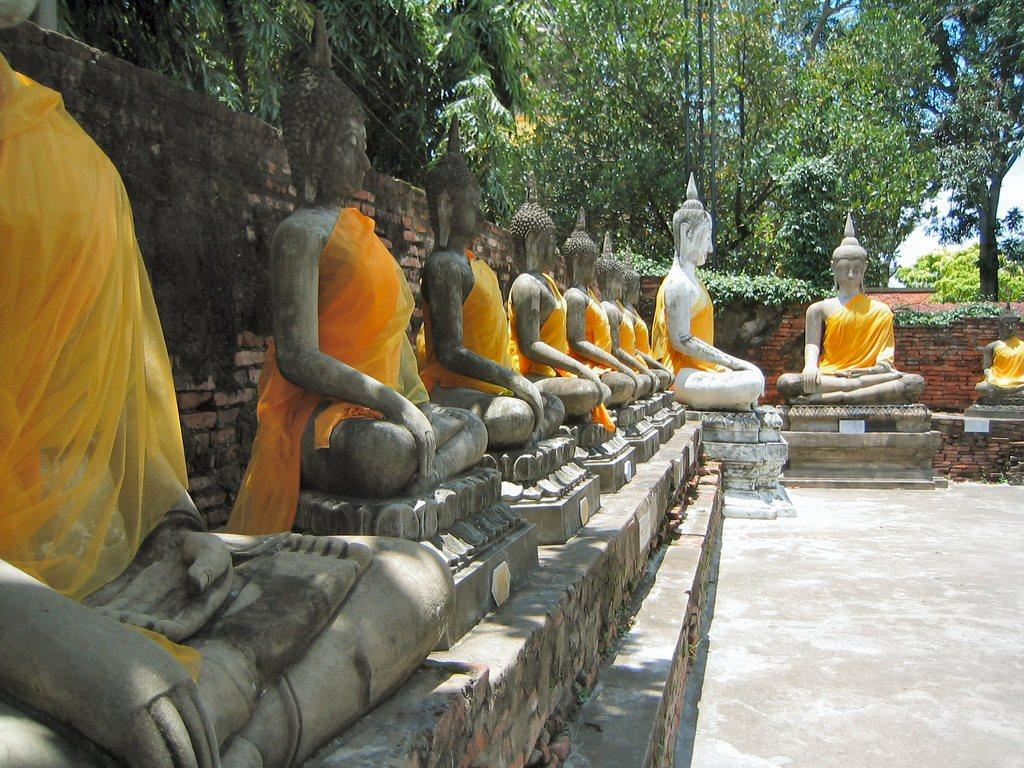What type of statues can be seen in the image? There are buddha statues in the image. What color are the clothes on the statues? The statues have yellow-colored clothes. What is the background of the image? There is a wall in the image, and trees and the sky are visible. What type of stamp can be seen on the wall in the image? There is no stamp present on the wall in the image. What process is being depicted in the image? The image does not depict a process; it shows buddha statues with yellow-colored clothes in front of a wall, trees, and the sky. 